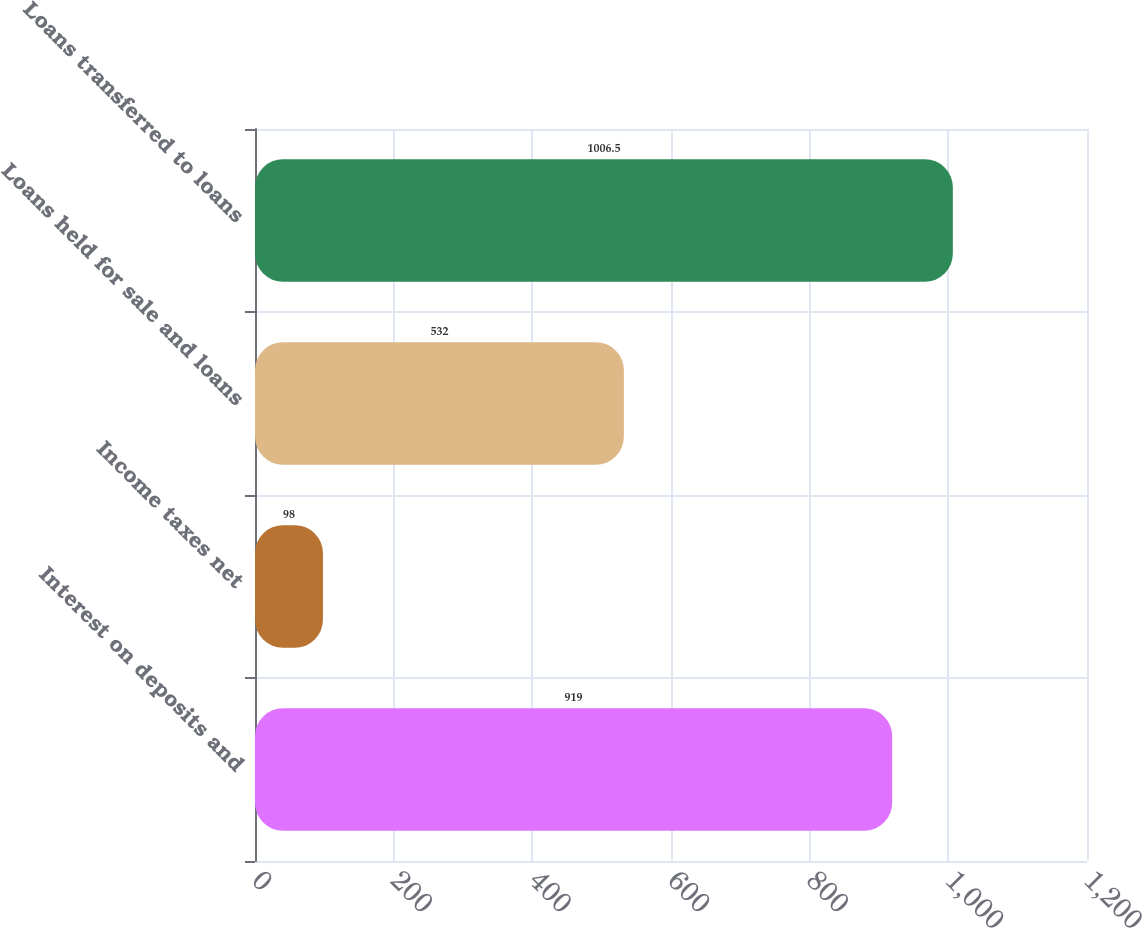Convert chart. <chart><loc_0><loc_0><loc_500><loc_500><bar_chart><fcel>Interest on deposits and<fcel>Income taxes net<fcel>Loans held for sale and loans<fcel>Loans transferred to loans<nl><fcel>919<fcel>98<fcel>532<fcel>1006.5<nl></chart> 